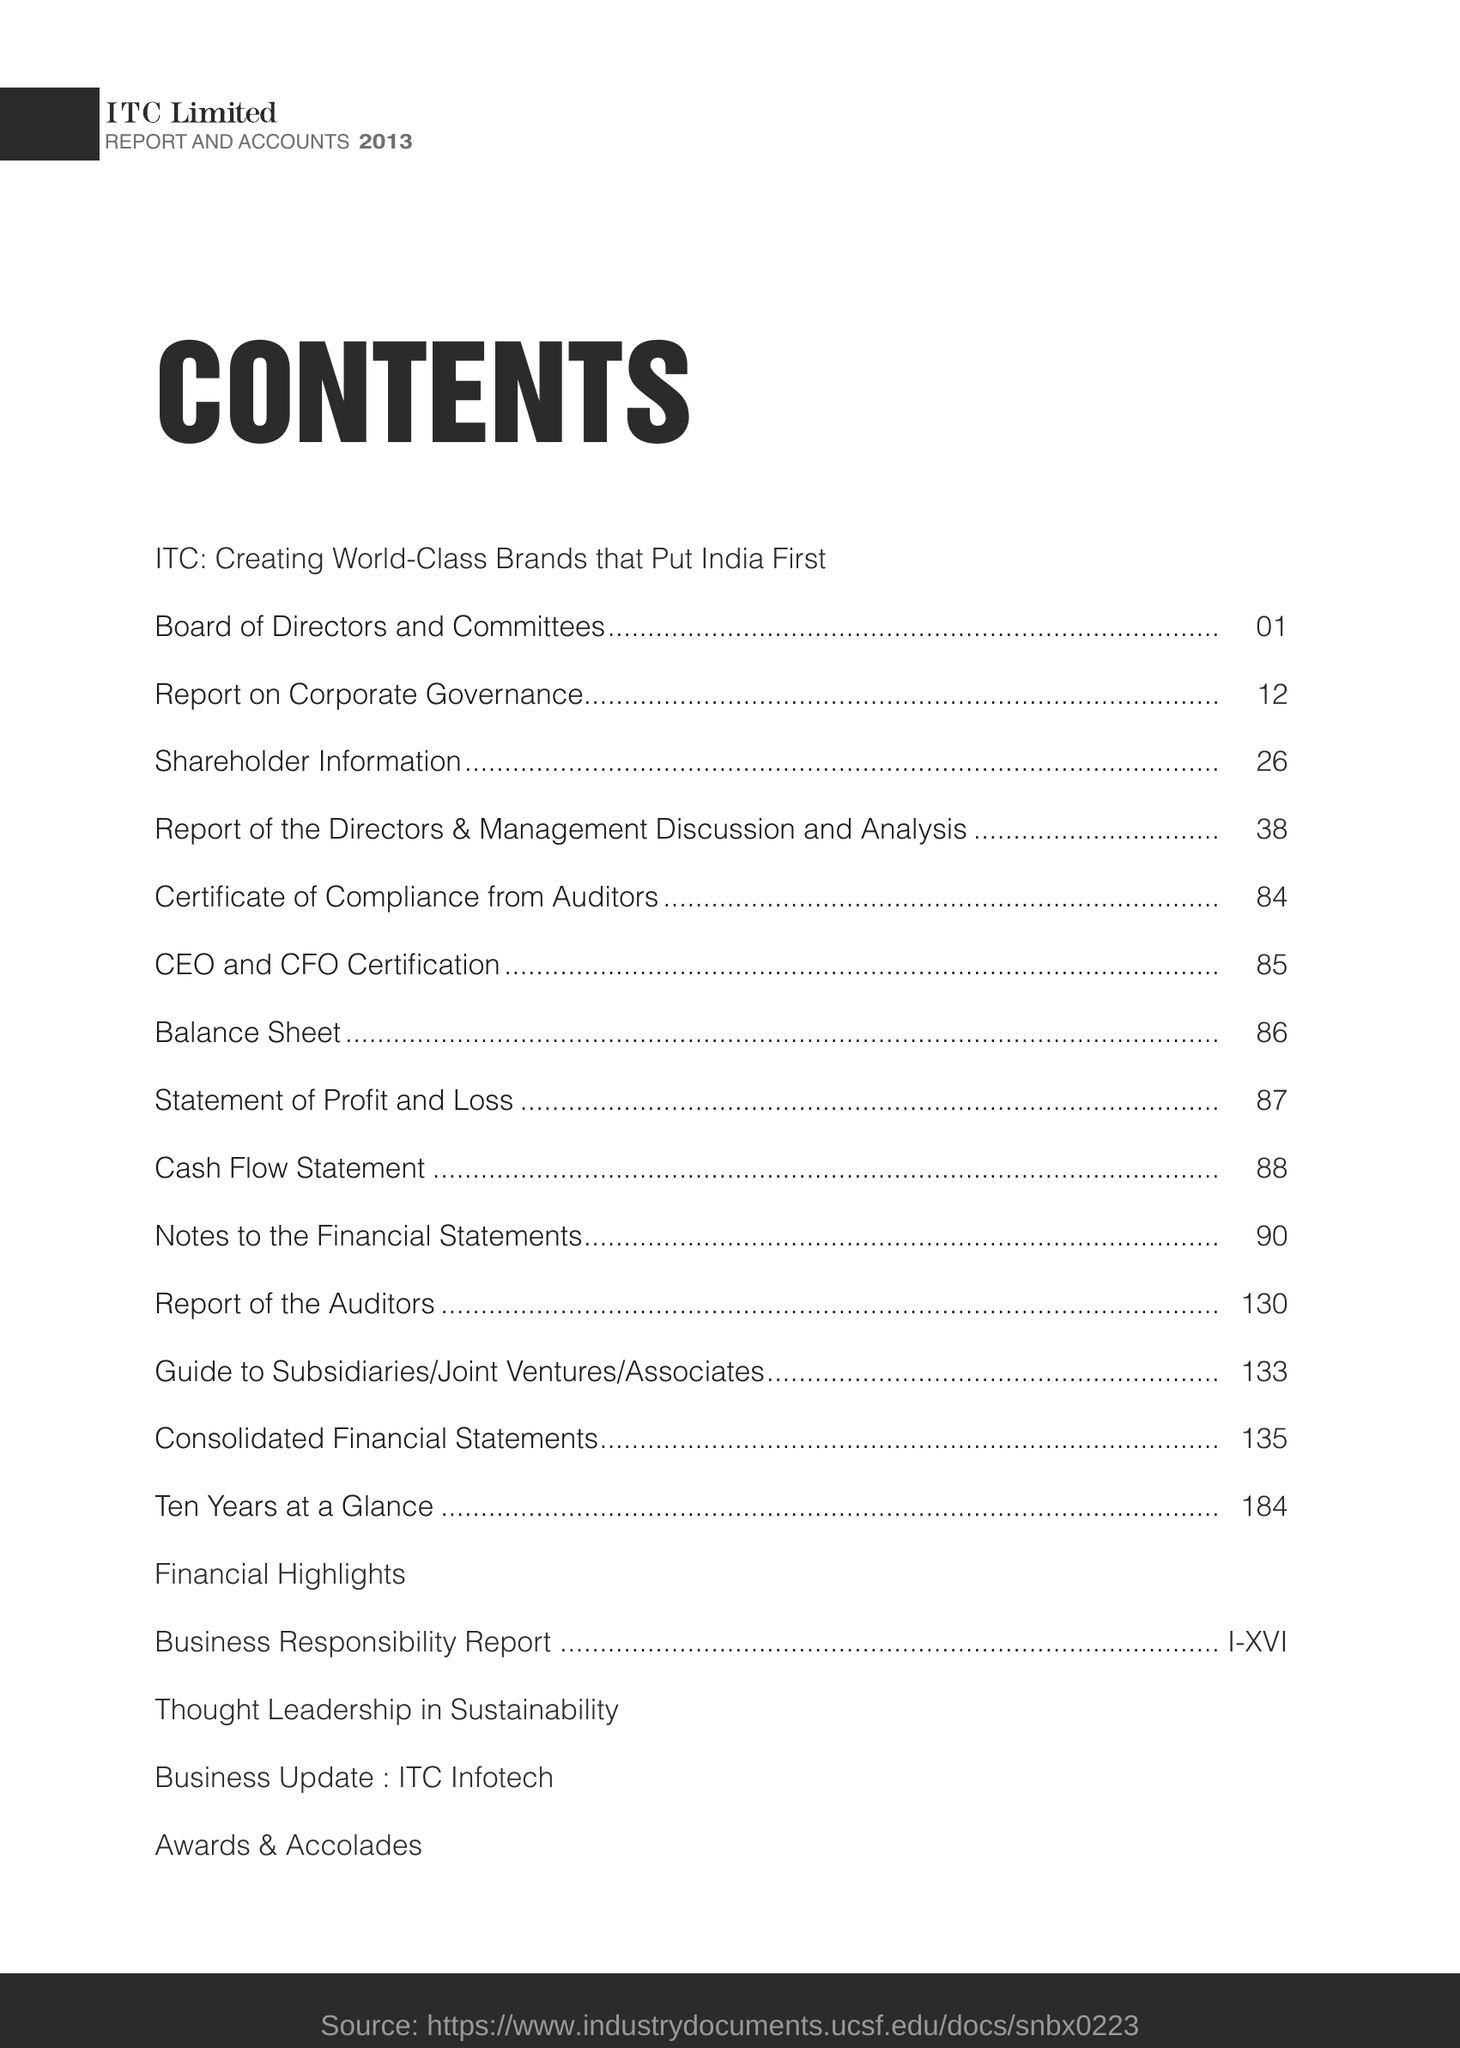What is the Page Number for Shareholders Information ?
Your answer should be very brief. 26. What is the Page Number for cash flow statement ?
Give a very brief answer. 88. Which topic showing page number "86" ?
Ensure brevity in your answer.  Balance Sheet. 